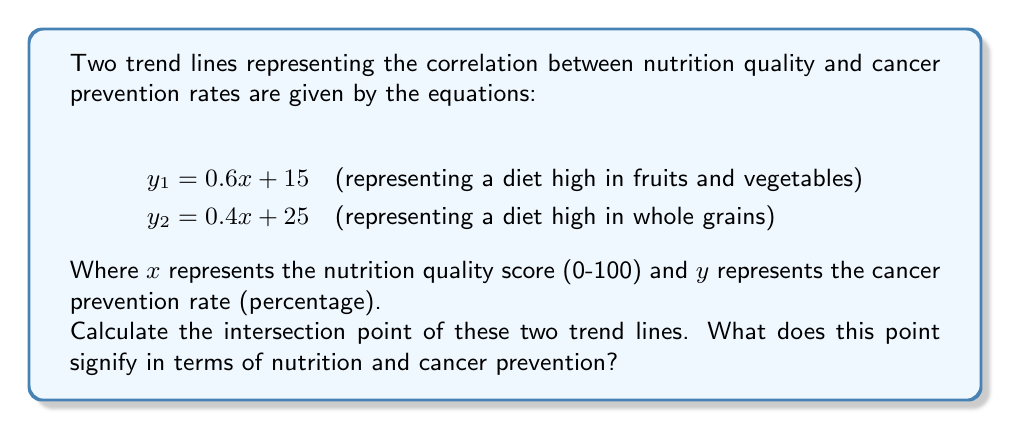What is the answer to this math problem? To find the intersection point of the two trend lines, we need to solve the system of equations:

$$y_1 = 0.6x + 15$$
$$y_2 = 0.4x + 25$$

At the intersection point, $y_1 = y_2$, so we can set the equations equal to each other:

$$0.6x + 15 = 0.4x + 25$$

Now, let's solve for $x$:

1) Subtract $0.4x$ from both sides:
   $$0.2x + 15 = 25$$

2) Subtract 15 from both sides:
   $$0.2x = 10$$

3) Divide both sides by 0.2:
   $$x = 50$$

Now that we have the $x$-coordinate, we can find the $y$-coordinate by plugging $x = 50$ into either of the original equations. Let's use the first equation:

$$y = 0.6(50) + 15 = 30 + 15 = 45$$

Therefore, the intersection point is $(50, 45)$.

This point signifies that at a nutrition quality score of 50, both diets (high in fruits and vegetables, and high in whole grains) result in the same cancer prevention rate of 45%. It represents the point where the two dietary approaches are equally effective in preventing cancer.
Answer: The intersection point is $(50, 45)$, indicating that at a nutrition quality score of 50, both dietary approaches result in a 45% cancer prevention rate. 